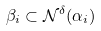<formula> <loc_0><loc_0><loc_500><loc_500>\beta _ { i } \subset \mathcal { N } ^ { \delta } ( \alpha _ { i } )</formula> 